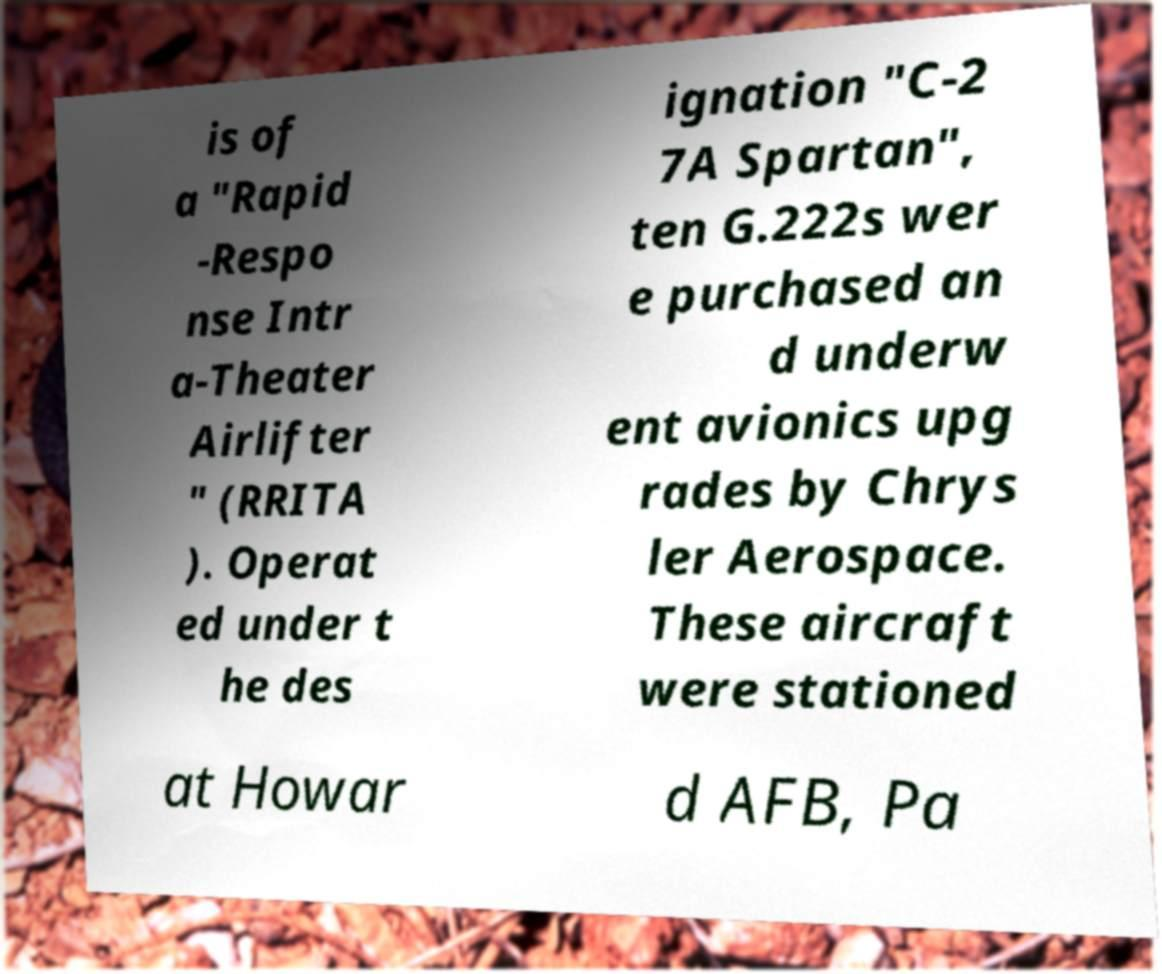Could you extract and type out the text from this image? is of a "Rapid -Respo nse Intr a-Theater Airlifter " (RRITA ). Operat ed under t he des ignation "C-2 7A Spartan", ten G.222s wer e purchased an d underw ent avionics upg rades by Chrys ler Aerospace. These aircraft were stationed at Howar d AFB, Pa 